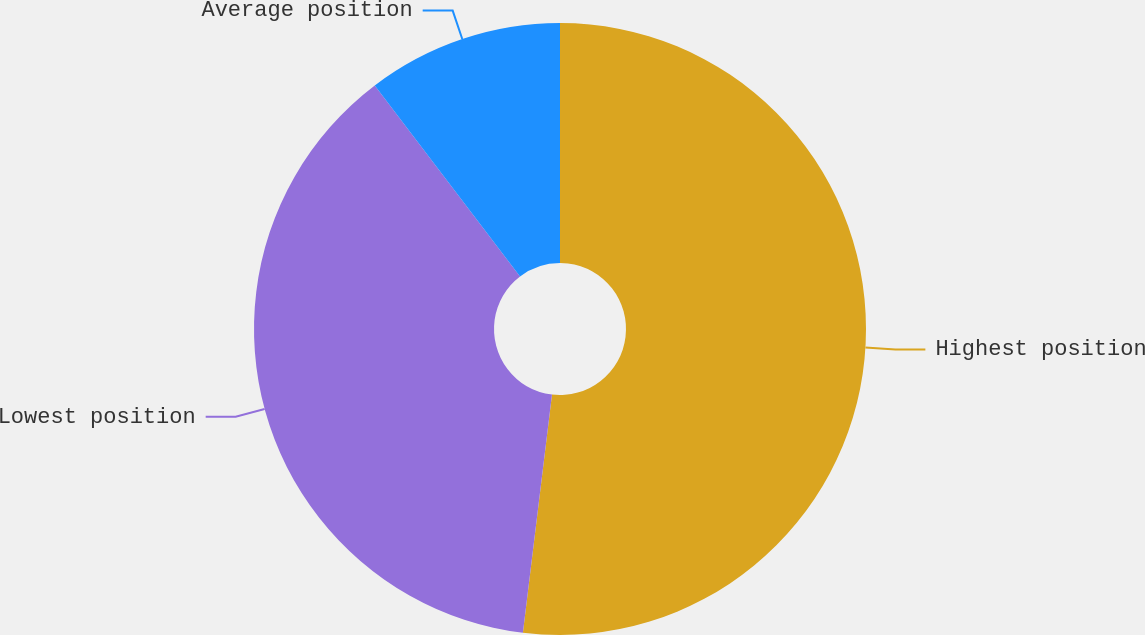<chart> <loc_0><loc_0><loc_500><loc_500><pie_chart><fcel>Highest position<fcel>Lowest position<fcel>Average position<nl><fcel>51.94%<fcel>37.72%<fcel>10.35%<nl></chart> 